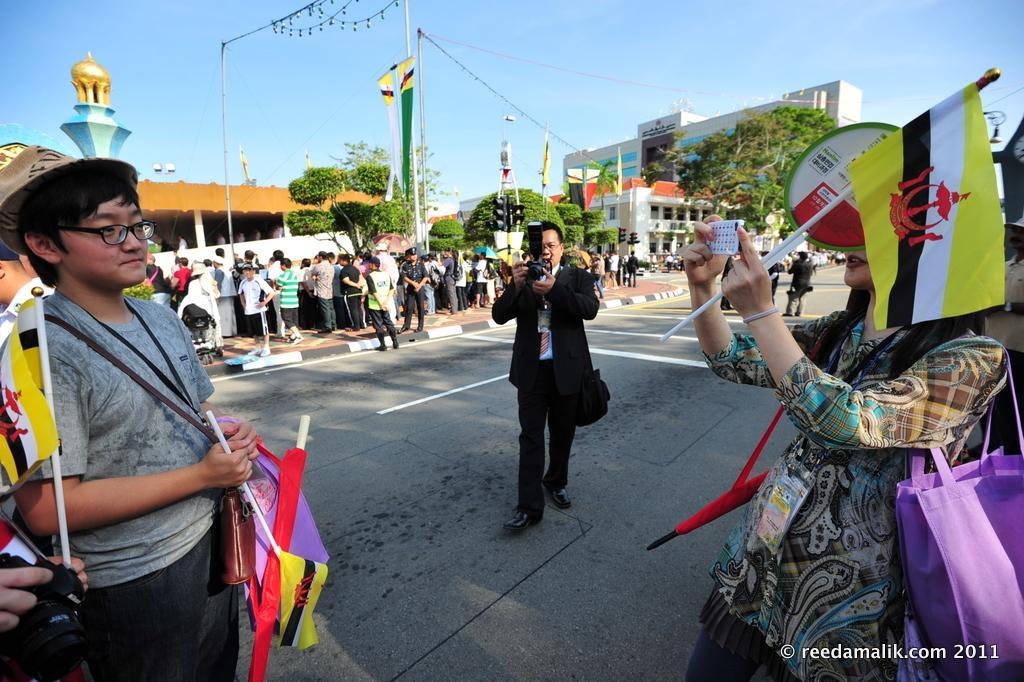How would you summarize this image in a sentence or two? This image consists of many people. It is clicked on the road. In the background, there are buildings along with the trees. In the front, the persons are wearing bags and holding flags. 